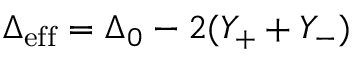<formula> <loc_0><loc_0><loc_500><loc_500>\Delta _ { e f f } = \Delta _ { 0 } - 2 ( Y _ { + } + Y _ { - } )</formula> 